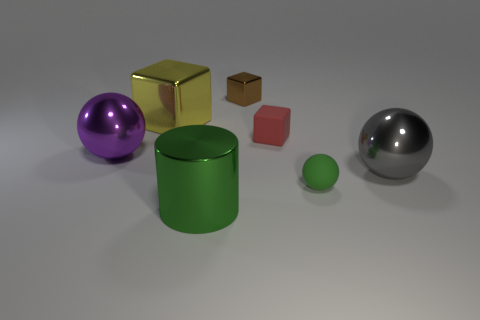Do the brown metal block and the rubber thing that is behind the purple shiny ball have the same size?
Ensure brevity in your answer.  Yes. There is a rubber thing behind the big gray shiny ball; are there any tiny rubber spheres that are in front of it?
Your response must be concise. Yes. There is a matte thing that is in front of the large gray object; what shape is it?
Make the answer very short. Sphere. There is a small object that is the same color as the metal cylinder; what material is it?
Provide a short and direct response. Rubber. There is a large sphere that is on the left side of the large metallic thing behind the tiny matte cube; what color is it?
Keep it short and to the point. Purple. Is the size of the green shiny thing the same as the purple metallic object?
Offer a terse response. Yes. What material is the other tiny thing that is the same shape as the small brown object?
Your answer should be compact. Rubber. What number of red cubes are the same size as the brown block?
Make the answer very short. 1. What color is the tiny cube that is the same material as the cylinder?
Keep it short and to the point. Brown. Are there fewer brown matte balls than small red matte cubes?
Your response must be concise. Yes. 